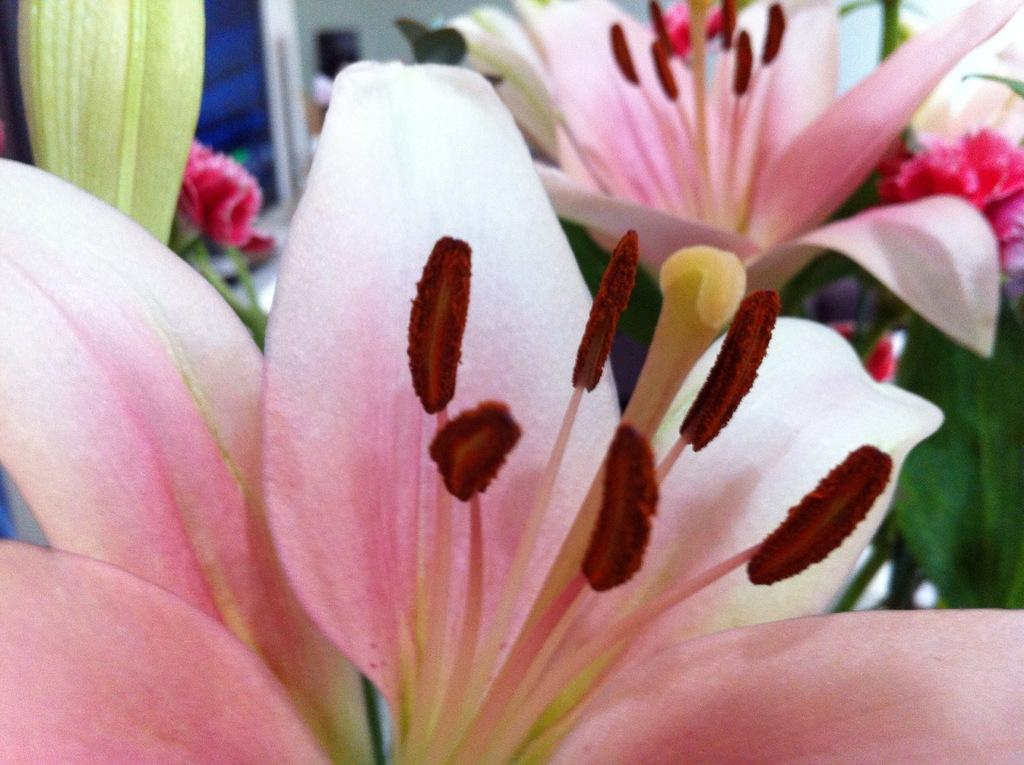What is the main subject of the image? The main subject of the image is many flowers. Can you describe the flowers in the image? The flowers have different colors. Are there any other elements related to plants in the image? Yes, there is a leaf in the image. What type of jelly is being used to attack the flowers in the image? There is no jelly or attack present in the image; it features flowers with different colors and a leaf. Can you identify the actor who is watering the flowers in the image? There is no actor or watering activity depicted in the image; it only shows flowers and a leaf. 